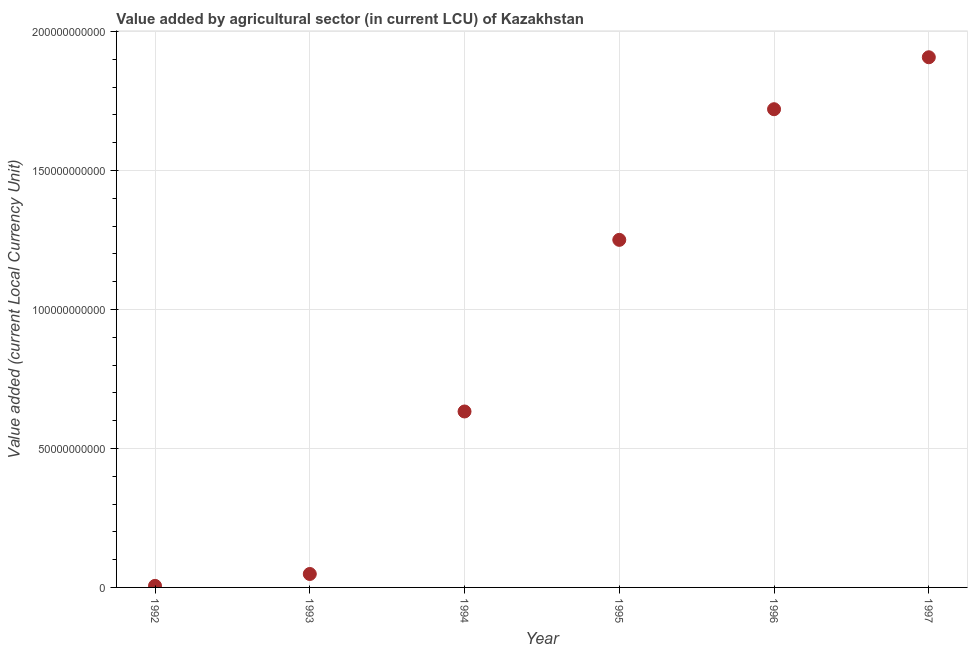What is the value added by agriculture sector in 1994?
Provide a short and direct response. 6.33e+1. Across all years, what is the maximum value added by agriculture sector?
Make the answer very short. 1.91e+11. Across all years, what is the minimum value added by agriculture sector?
Provide a short and direct response. 5.63e+08. What is the sum of the value added by agriculture sector?
Your response must be concise. 5.57e+11. What is the difference between the value added by agriculture sector in 1995 and 1997?
Give a very brief answer. -6.57e+1. What is the average value added by agriculture sector per year?
Keep it short and to the point. 9.28e+1. What is the median value added by agriculture sector?
Provide a succinct answer. 9.42e+1. In how many years, is the value added by agriculture sector greater than 60000000000 LCU?
Provide a succinct answer. 4. What is the ratio of the value added by agriculture sector in 1992 to that in 1995?
Your answer should be very brief. 0. Is the difference between the value added by agriculture sector in 1992 and 1993 greater than the difference between any two years?
Provide a short and direct response. No. What is the difference between the highest and the second highest value added by agriculture sector?
Provide a short and direct response. 1.87e+1. What is the difference between the highest and the lowest value added by agriculture sector?
Keep it short and to the point. 1.90e+11. In how many years, is the value added by agriculture sector greater than the average value added by agriculture sector taken over all years?
Make the answer very short. 3. What is the difference between two consecutive major ticks on the Y-axis?
Make the answer very short. 5.00e+1. Are the values on the major ticks of Y-axis written in scientific E-notation?
Keep it short and to the point. No. What is the title of the graph?
Offer a terse response. Value added by agricultural sector (in current LCU) of Kazakhstan. What is the label or title of the Y-axis?
Make the answer very short. Value added (current Local Currency Unit). What is the Value added (current Local Currency Unit) in 1992?
Ensure brevity in your answer.  5.63e+08. What is the Value added (current Local Currency Unit) in 1993?
Offer a very short reply. 4.84e+09. What is the Value added (current Local Currency Unit) in 1994?
Your answer should be compact. 6.33e+1. What is the Value added (current Local Currency Unit) in 1995?
Your answer should be very brief. 1.25e+11. What is the Value added (current Local Currency Unit) in 1996?
Keep it short and to the point. 1.72e+11. What is the Value added (current Local Currency Unit) in 1997?
Offer a very short reply. 1.91e+11. What is the difference between the Value added (current Local Currency Unit) in 1992 and 1993?
Offer a very short reply. -4.27e+09. What is the difference between the Value added (current Local Currency Unit) in 1992 and 1994?
Offer a very short reply. -6.27e+1. What is the difference between the Value added (current Local Currency Unit) in 1992 and 1995?
Provide a short and direct response. -1.24e+11. What is the difference between the Value added (current Local Currency Unit) in 1992 and 1996?
Offer a terse response. -1.71e+11. What is the difference between the Value added (current Local Currency Unit) in 1992 and 1997?
Your answer should be compact. -1.90e+11. What is the difference between the Value added (current Local Currency Unit) in 1993 and 1994?
Ensure brevity in your answer.  -5.85e+1. What is the difference between the Value added (current Local Currency Unit) in 1993 and 1995?
Provide a short and direct response. -1.20e+11. What is the difference between the Value added (current Local Currency Unit) in 1993 and 1996?
Make the answer very short. -1.67e+11. What is the difference between the Value added (current Local Currency Unit) in 1993 and 1997?
Provide a short and direct response. -1.86e+11. What is the difference between the Value added (current Local Currency Unit) in 1994 and 1995?
Your response must be concise. -6.17e+1. What is the difference between the Value added (current Local Currency Unit) in 1994 and 1996?
Keep it short and to the point. -1.09e+11. What is the difference between the Value added (current Local Currency Unit) in 1994 and 1997?
Provide a succinct answer. -1.27e+11. What is the difference between the Value added (current Local Currency Unit) in 1995 and 1996?
Your answer should be compact. -4.70e+1. What is the difference between the Value added (current Local Currency Unit) in 1995 and 1997?
Your answer should be very brief. -6.57e+1. What is the difference between the Value added (current Local Currency Unit) in 1996 and 1997?
Provide a succinct answer. -1.87e+1. What is the ratio of the Value added (current Local Currency Unit) in 1992 to that in 1993?
Provide a short and direct response. 0.12. What is the ratio of the Value added (current Local Currency Unit) in 1992 to that in 1994?
Offer a terse response. 0.01. What is the ratio of the Value added (current Local Currency Unit) in 1992 to that in 1995?
Keep it short and to the point. 0.01. What is the ratio of the Value added (current Local Currency Unit) in 1992 to that in 1996?
Provide a short and direct response. 0. What is the ratio of the Value added (current Local Currency Unit) in 1992 to that in 1997?
Your response must be concise. 0. What is the ratio of the Value added (current Local Currency Unit) in 1993 to that in 1994?
Ensure brevity in your answer.  0.08. What is the ratio of the Value added (current Local Currency Unit) in 1993 to that in 1995?
Give a very brief answer. 0.04. What is the ratio of the Value added (current Local Currency Unit) in 1993 to that in 1996?
Provide a succinct answer. 0.03. What is the ratio of the Value added (current Local Currency Unit) in 1993 to that in 1997?
Your response must be concise. 0.03. What is the ratio of the Value added (current Local Currency Unit) in 1994 to that in 1995?
Ensure brevity in your answer.  0.51. What is the ratio of the Value added (current Local Currency Unit) in 1994 to that in 1996?
Make the answer very short. 0.37. What is the ratio of the Value added (current Local Currency Unit) in 1994 to that in 1997?
Make the answer very short. 0.33. What is the ratio of the Value added (current Local Currency Unit) in 1995 to that in 1996?
Give a very brief answer. 0.73. What is the ratio of the Value added (current Local Currency Unit) in 1995 to that in 1997?
Make the answer very short. 0.66. What is the ratio of the Value added (current Local Currency Unit) in 1996 to that in 1997?
Give a very brief answer. 0.9. 